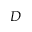<formula> <loc_0><loc_0><loc_500><loc_500>D</formula> 